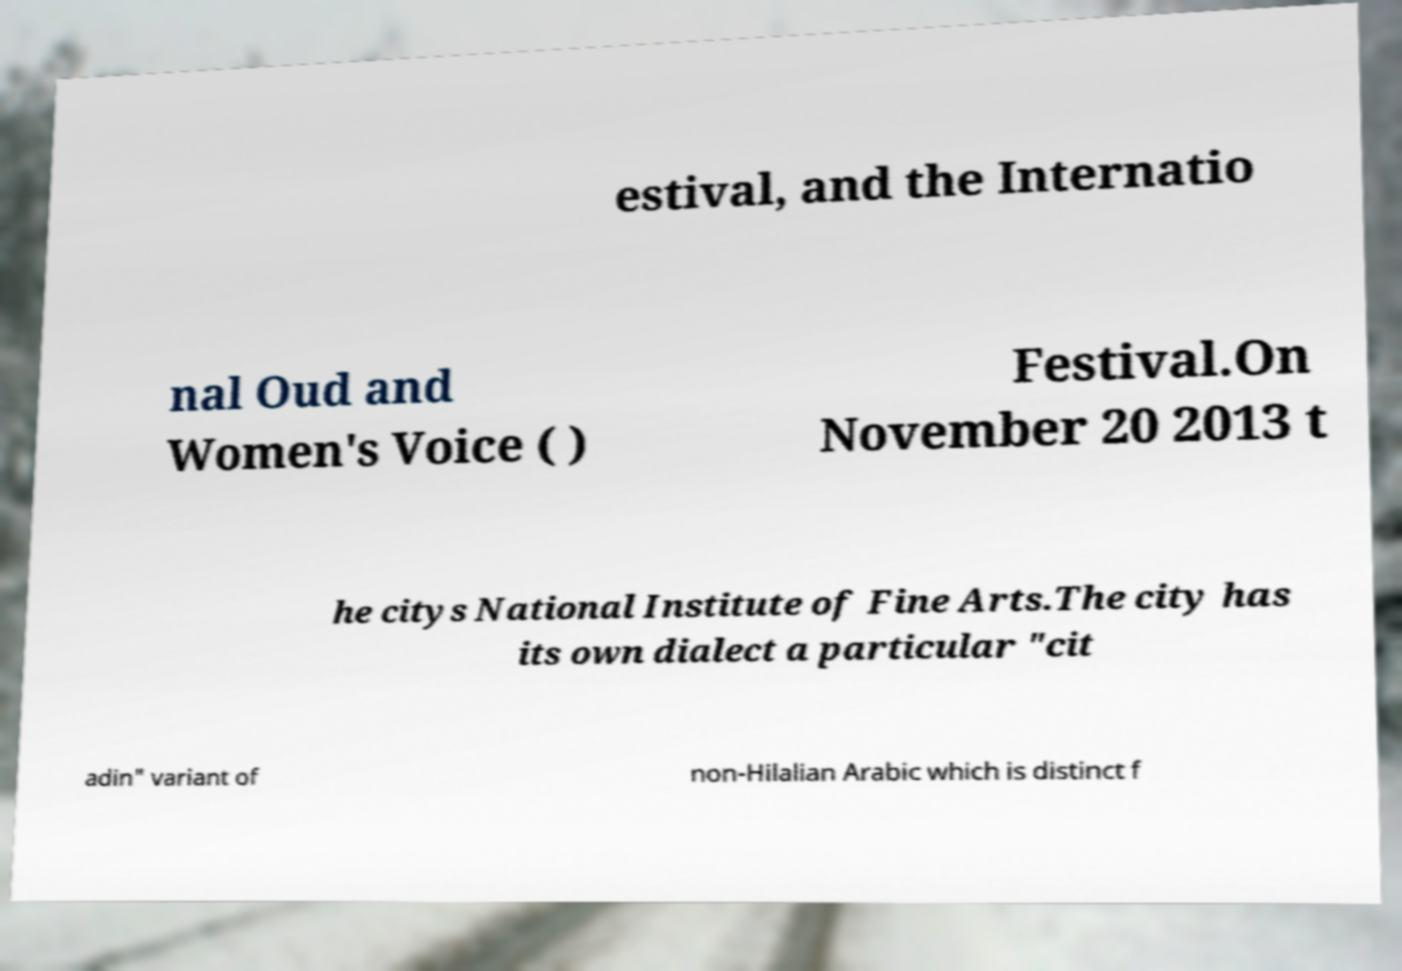Could you assist in decoding the text presented in this image and type it out clearly? estival, and the Internatio nal Oud and Women's Voice ( ) Festival.On November 20 2013 t he citys National Institute of Fine Arts.The city has its own dialect a particular "cit adin" variant of non-Hilalian Arabic which is distinct f 